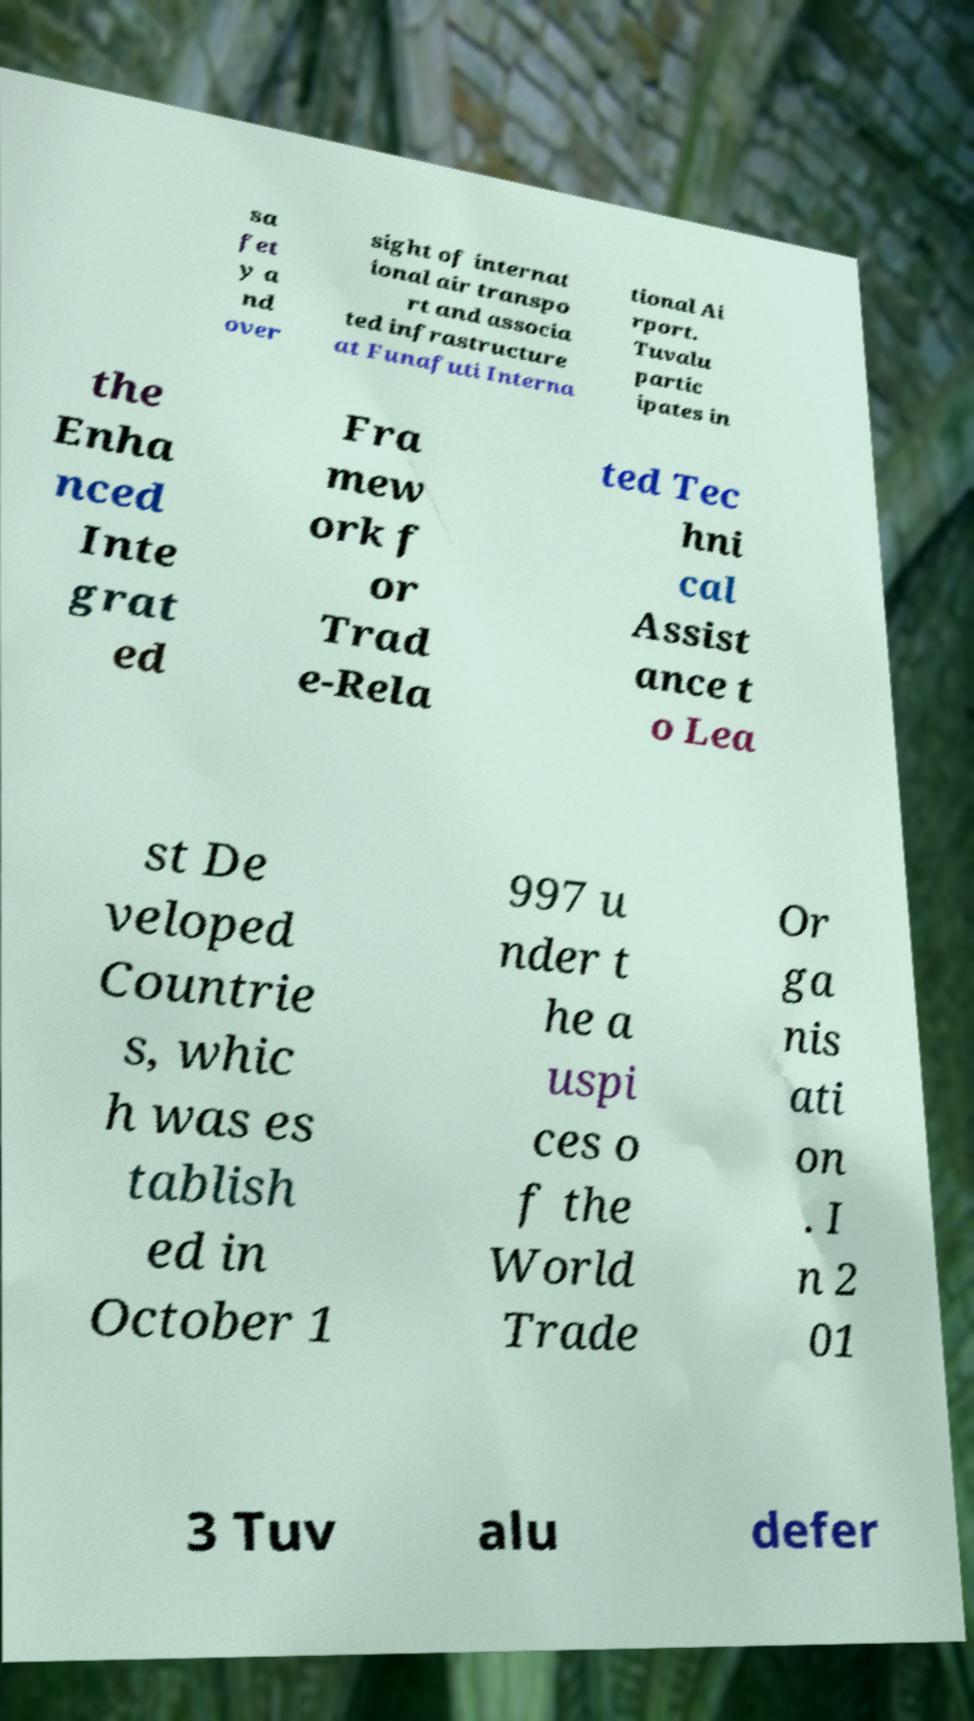I need the written content from this picture converted into text. Can you do that? sa fet y a nd over sight of internat ional air transpo rt and associa ted infrastructure at Funafuti Interna tional Ai rport. Tuvalu partic ipates in the Enha nced Inte grat ed Fra mew ork f or Trad e-Rela ted Tec hni cal Assist ance t o Lea st De veloped Countrie s, whic h was es tablish ed in October 1 997 u nder t he a uspi ces o f the World Trade Or ga nis ati on . I n 2 01 3 Tuv alu defer 